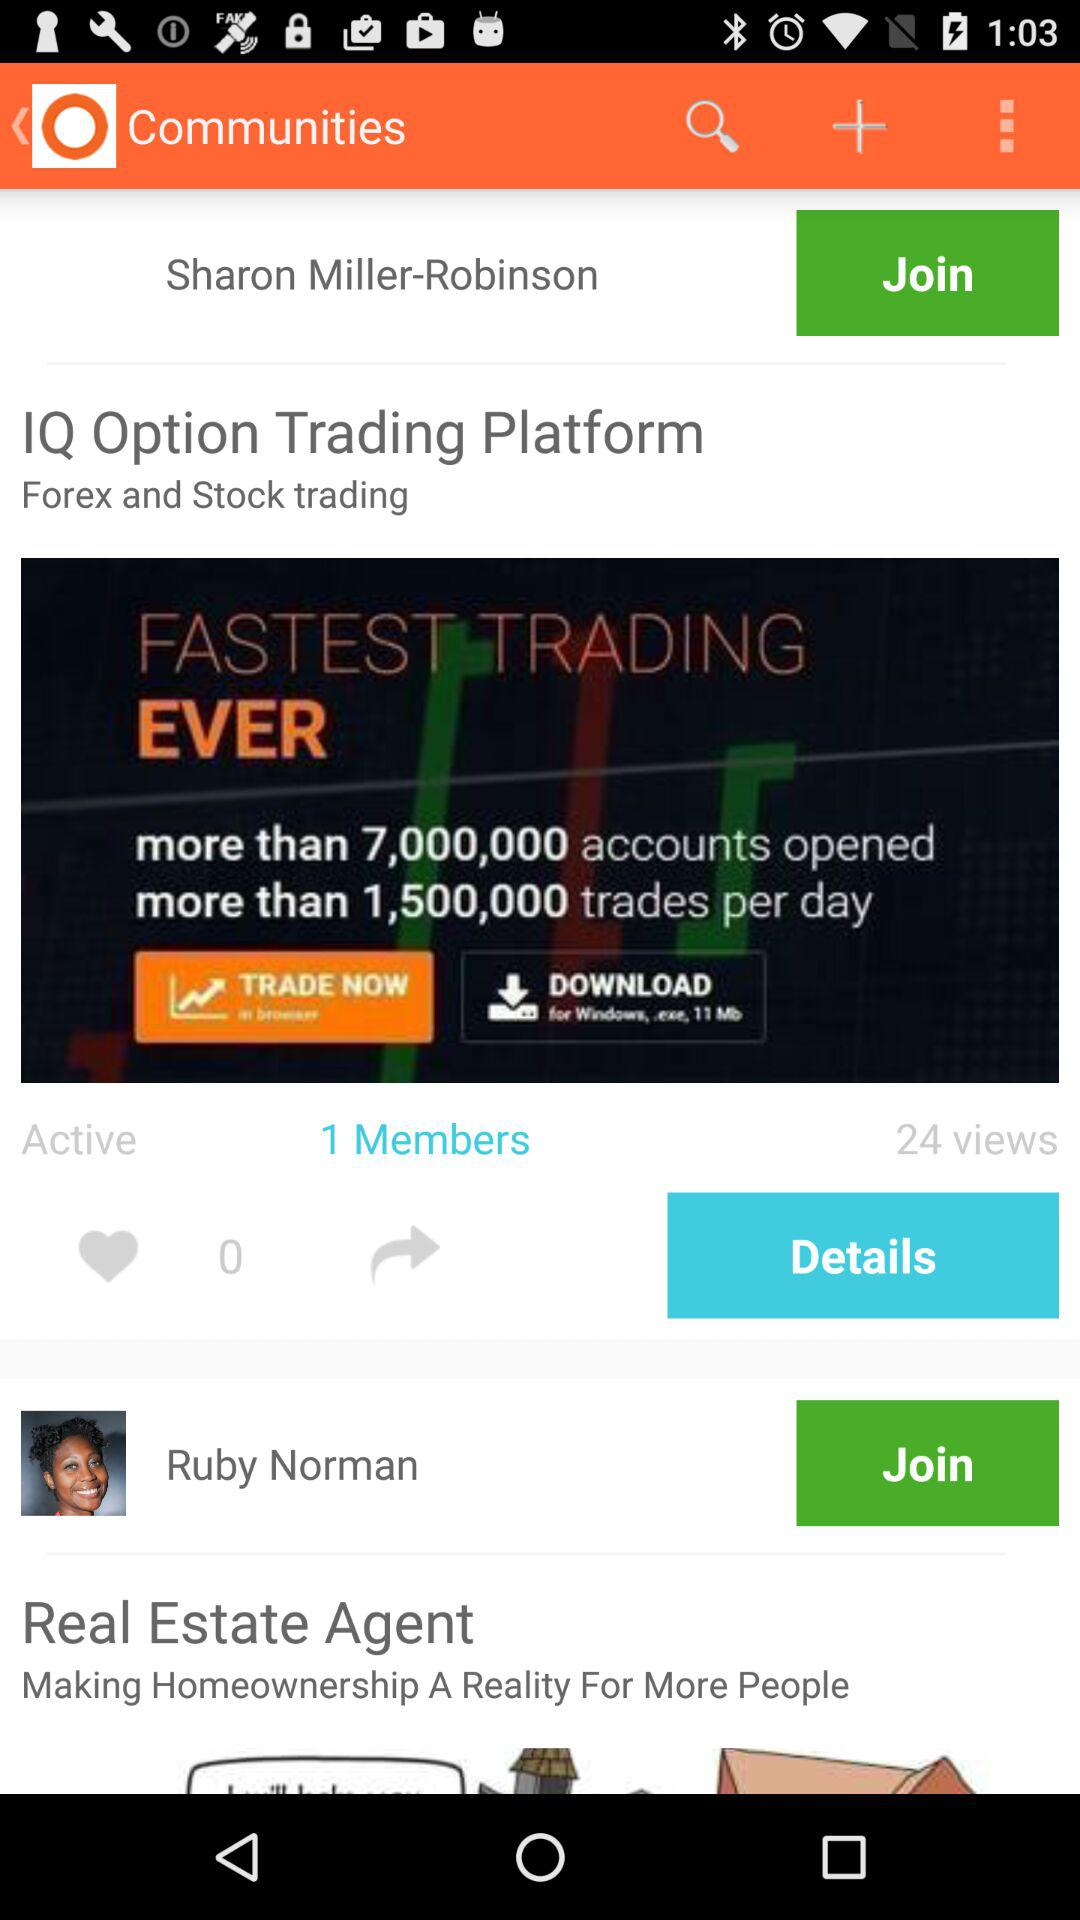How many views are there? There are 24 views. 